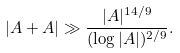Convert formula to latex. <formula><loc_0><loc_0><loc_500><loc_500>| A + A | \gg \frac { | A | ^ { 1 4 / 9 } } { ( \log | A | ) ^ { 2 / 9 } } .</formula> 